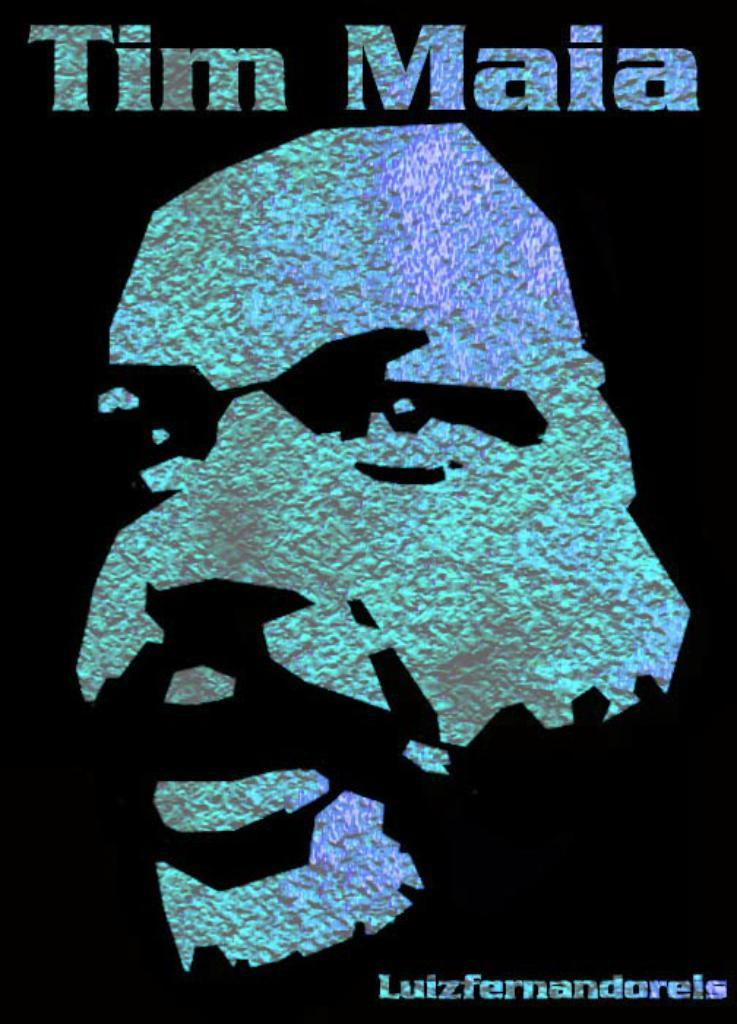<image>
Render a clear and concise summary of the photo. a poster that has maia written on it 